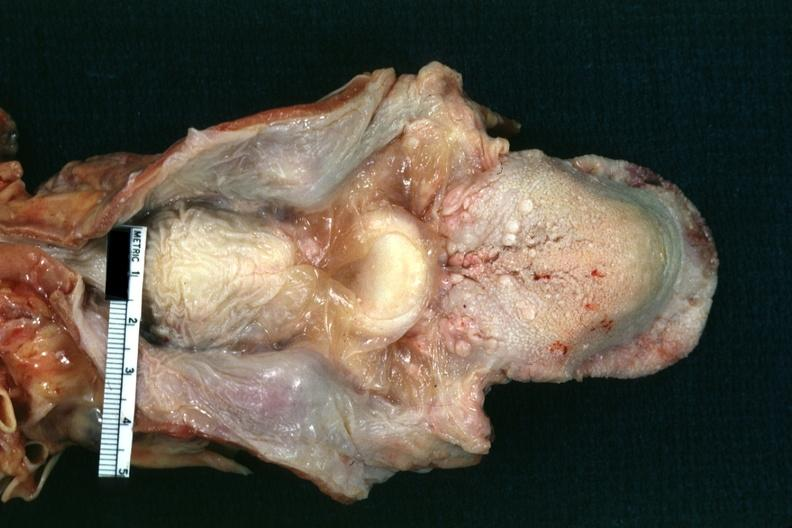s larynx present?
Answer the question using a single word or phrase. Yes 